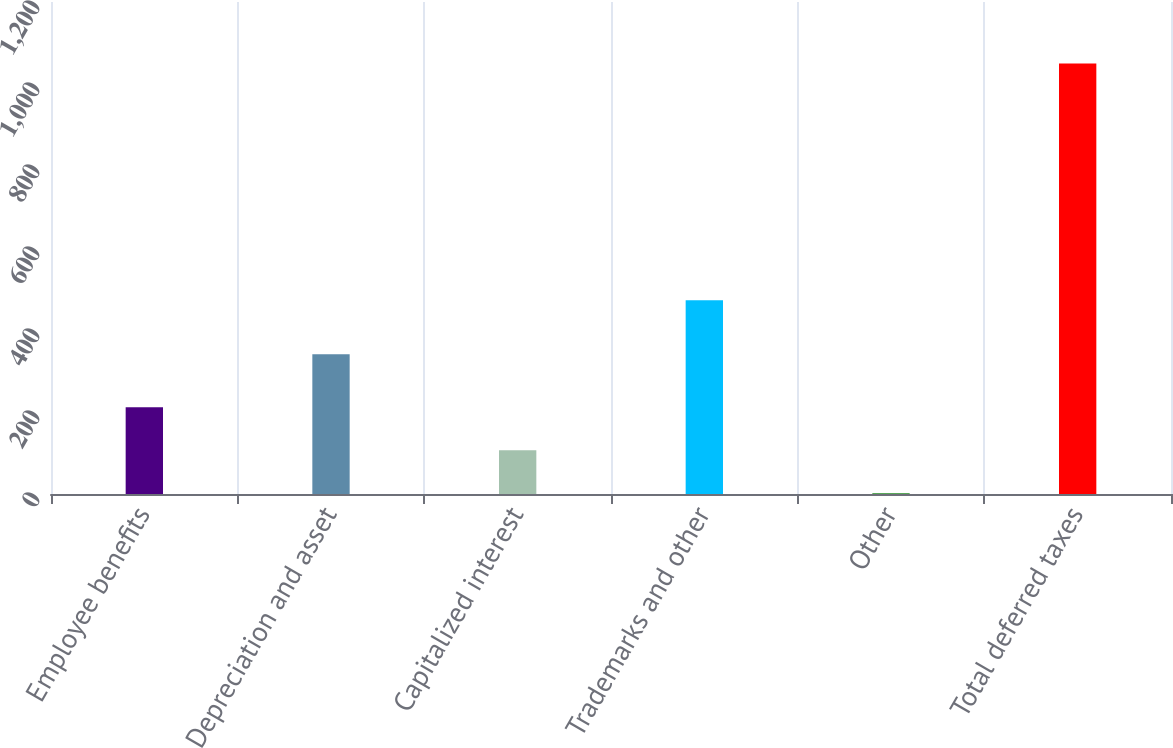Convert chart. <chart><loc_0><loc_0><loc_500><loc_500><bar_chart><fcel>Employee benefits<fcel>Depreciation and asset<fcel>Capitalized interest<fcel>Trademarks and other<fcel>Other<fcel>Total deferred taxes<nl><fcel>211.7<fcel>340.8<fcel>106.9<fcel>472.4<fcel>2.1<fcel>1050.1<nl></chart> 